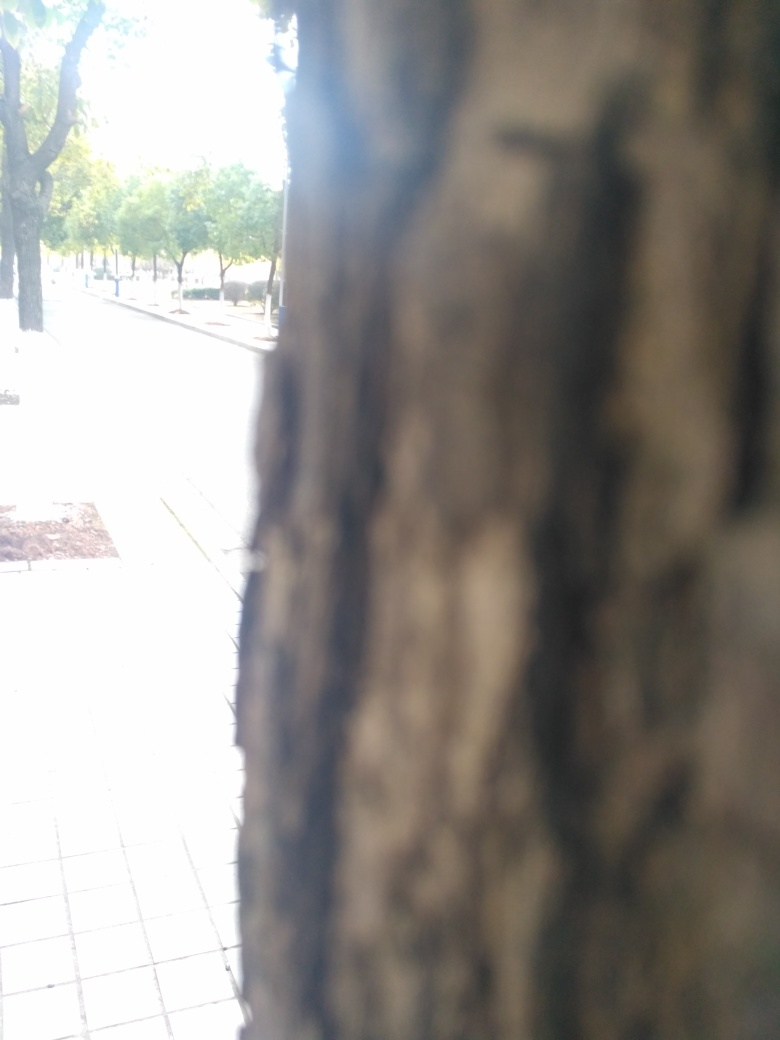Describe the focus of this photograph. The photograph is focused on the bark of a tree in the foreground, which has a rough and textured surface. This close-up shot blurs the background, including the trees that line the path. What does the blurred background suggest about the location? Although details are obscure, the blurred background suggests a pathway lined with trees, indicating an area designed for walking, possibly an urban park or a tree-lined street within a city. 